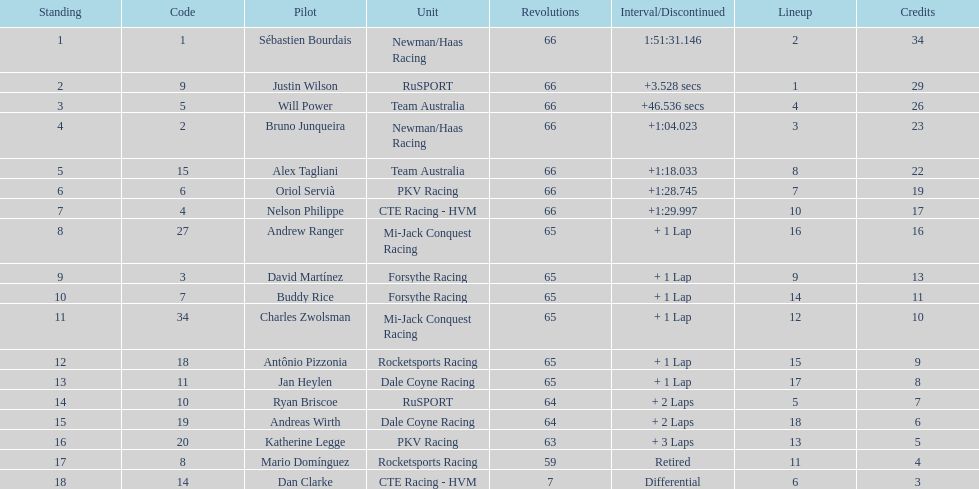Parse the full table. {'header': ['Standing', 'Code', 'Pilot', 'Unit', 'Revolutions', 'Interval/Discontinued', 'Lineup', 'Credits'], 'rows': [['1', '1', 'Sébastien Bourdais', 'Newman/Haas Racing', '66', '1:51:31.146', '2', '34'], ['2', '9', 'Justin Wilson', 'RuSPORT', '66', '+3.528 secs', '1', '29'], ['3', '5', 'Will Power', 'Team Australia', '66', '+46.536 secs', '4', '26'], ['4', '2', 'Bruno Junqueira', 'Newman/Haas Racing', '66', '+1:04.023', '3', '23'], ['5', '15', 'Alex Tagliani', 'Team Australia', '66', '+1:18.033', '8', '22'], ['6', '6', 'Oriol Servià', 'PKV Racing', '66', '+1:28.745', '7', '19'], ['7', '4', 'Nelson Philippe', 'CTE Racing - HVM', '66', '+1:29.997', '10', '17'], ['8', '27', 'Andrew Ranger', 'Mi-Jack Conquest Racing', '65', '+ 1 Lap', '16', '16'], ['9', '3', 'David Martínez', 'Forsythe Racing', '65', '+ 1 Lap', '9', '13'], ['10', '7', 'Buddy Rice', 'Forsythe Racing', '65', '+ 1 Lap', '14', '11'], ['11', '34', 'Charles Zwolsman', 'Mi-Jack Conquest Racing', '65', '+ 1 Lap', '12', '10'], ['12', '18', 'Antônio Pizzonia', 'Rocketsports Racing', '65', '+ 1 Lap', '15', '9'], ['13', '11', 'Jan Heylen', 'Dale Coyne Racing', '65', '+ 1 Lap', '17', '8'], ['14', '10', 'Ryan Briscoe', 'RuSPORT', '64', '+ 2 Laps', '5', '7'], ['15', '19', 'Andreas Wirth', 'Dale Coyne Racing', '64', '+ 2 Laps', '18', '6'], ['16', '20', 'Katherine Legge', 'PKV Racing', '63', '+ 3 Laps', '13', '5'], ['17', '8', 'Mario Domínguez', 'Rocketsports Racing', '59', 'Retired', '11', '4'], ['18', '14', 'Dan Clarke', 'CTE Racing - HVM', '7', 'Differential', '6', '3']]} Who finished directly after the driver who finished in 1:28.745? Nelson Philippe. 